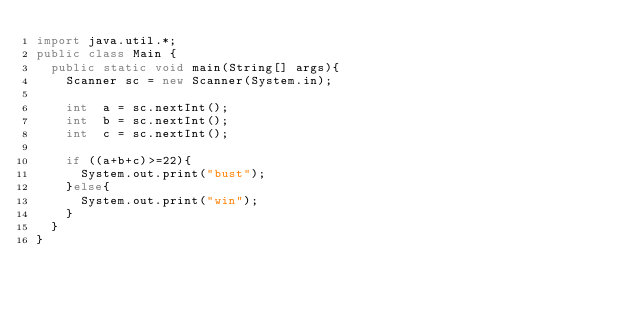Convert code to text. <code><loc_0><loc_0><loc_500><loc_500><_Java_>import java.util.*;
public class Main {
	public static void main(String[] args){
		Scanner sc = new Scanner(System.in);
		
		int  a = sc.nextInt();
		int  b = sc.nextInt();
		int  c = sc.nextInt();
		
		if ((a+b+c)>=22){
			System.out.print("bust");
		}else{
			System.out.print("win");
		}
	}
}</code> 